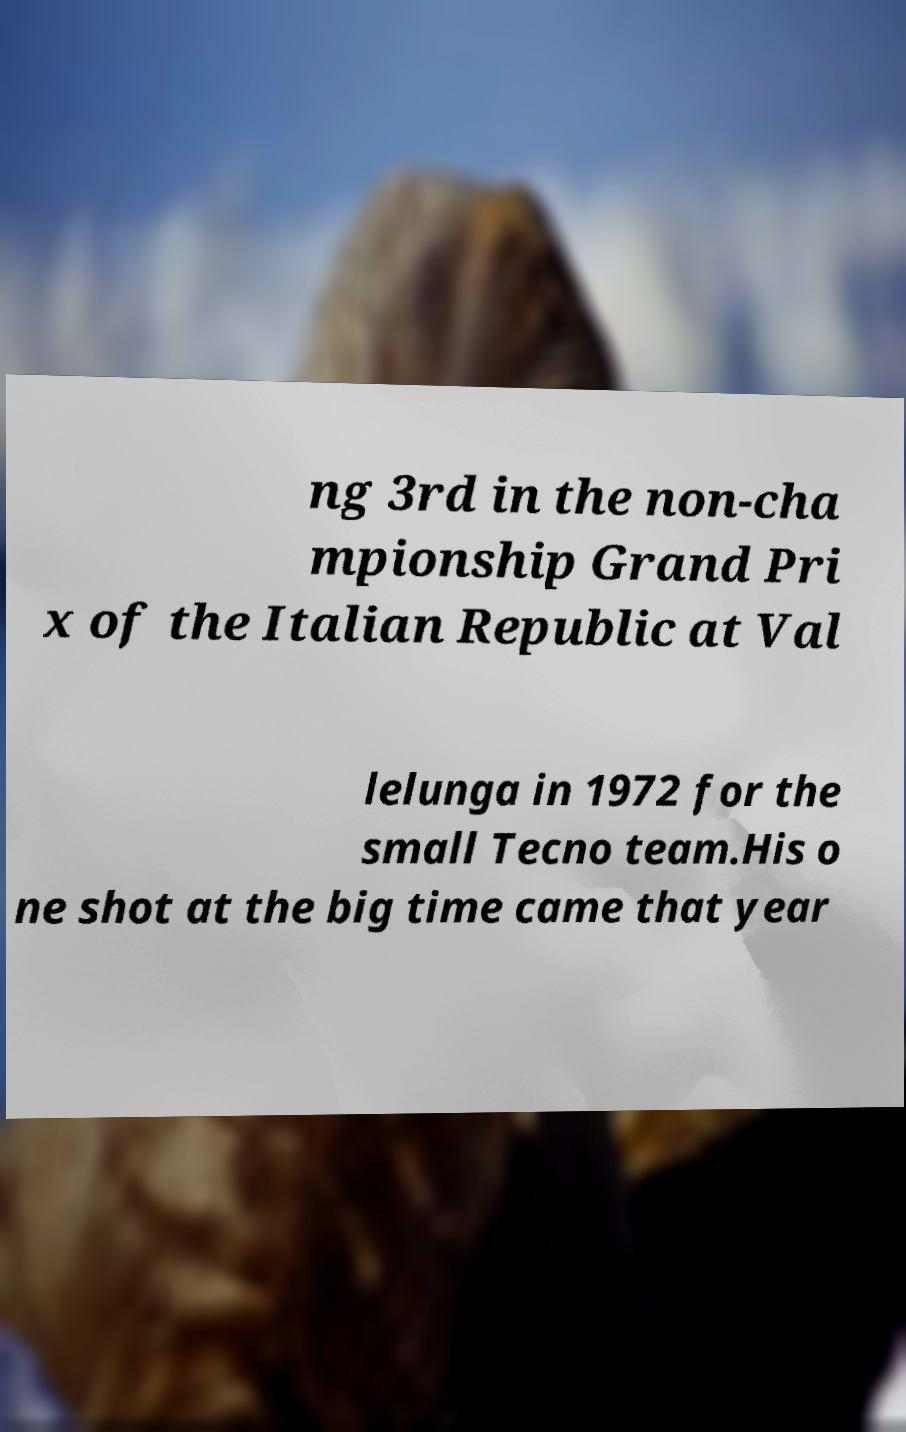I need the written content from this picture converted into text. Can you do that? ng 3rd in the non-cha mpionship Grand Pri x of the Italian Republic at Val lelunga in 1972 for the small Tecno team.His o ne shot at the big time came that year 